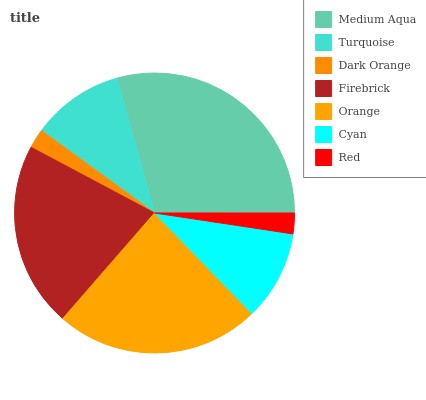Is Dark Orange the minimum?
Answer yes or no. Yes. Is Medium Aqua the maximum?
Answer yes or no. Yes. Is Turquoise the minimum?
Answer yes or no. No. Is Turquoise the maximum?
Answer yes or no. No. Is Medium Aqua greater than Turquoise?
Answer yes or no. Yes. Is Turquoise less than Medium Aqua?
Answer yes or no. Yes. Is Turquoise greater than Medium Aqua?
Answer yes or no. No. Is Medium Aqua less than Turquoise?
Answer yes or no. No. Is Turquoise the high median?
Answer yes or no. Yes. Is Turquoise the low median?
Answer yes or no. Yes. Is Orange the high median?
Answer yes or no. No. Is Dark Orange the low median?
Answer yes or no. No. 